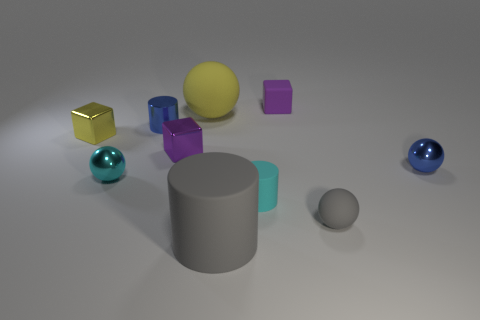Subtract all small blue balls. How many balls are left? 3 Subtract all cyan balls. How many balls are left? 3 Subtract all spheres. How many objects are left? 6 Subtract 1 cylinders. How many cylinders are left? 2 Subtract all yellow spheres. Subtract all yellow blocks. How many spheres are left? 3 Subtract all green blocks. How many red balls are left? 0 Subtract all tiny gray things. Subtract all large blue metal cylinders. How many objects are left? 9 Add 2 small cyan cylinders. How many small cyan cylinders are left? 3 Add 8 gray matte cylinders. How many gray matte cylinders exist? 9 Subtract 1 blue balls. How many objects are left? 9 